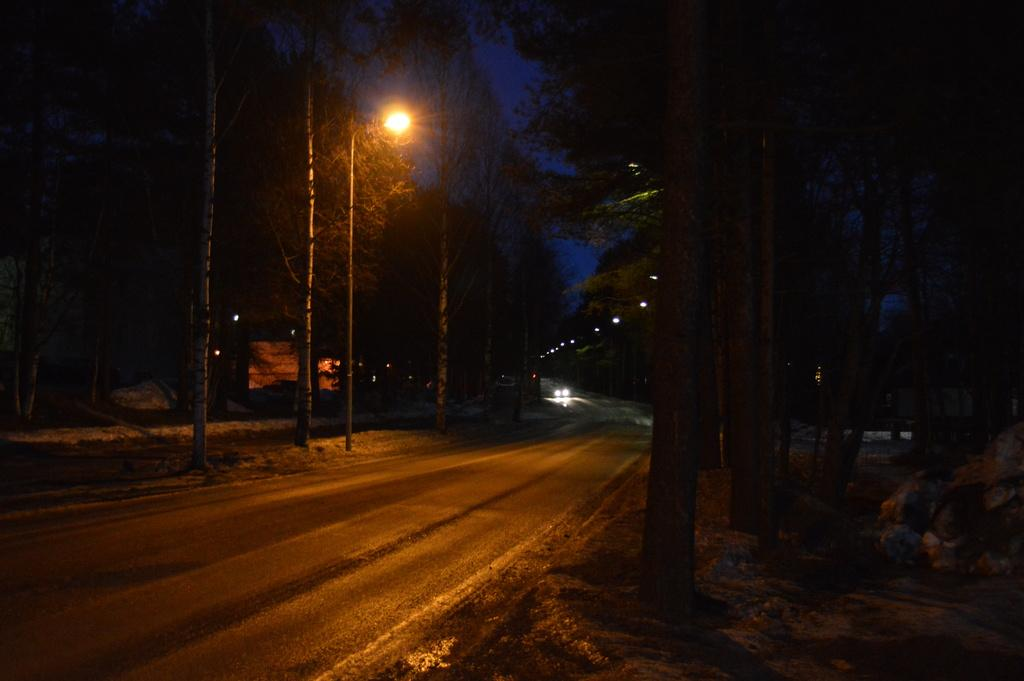What is the overall lighting condition in the image? The image is dark. What is the main feature of the image? There is a road in the image. What can be seen in the background of the image? There are vehicles in the background of the image. What is present on both sides of the road? There are street lights and trees on both sides of the road. What color is the crayon used to draw the dust in the image? There is no crayon or dust present in the image; it is a photograph of a road with street lights and trees. 